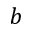<formula> <loc_0><loc_0><loc_500><loc_500>b</formula> 